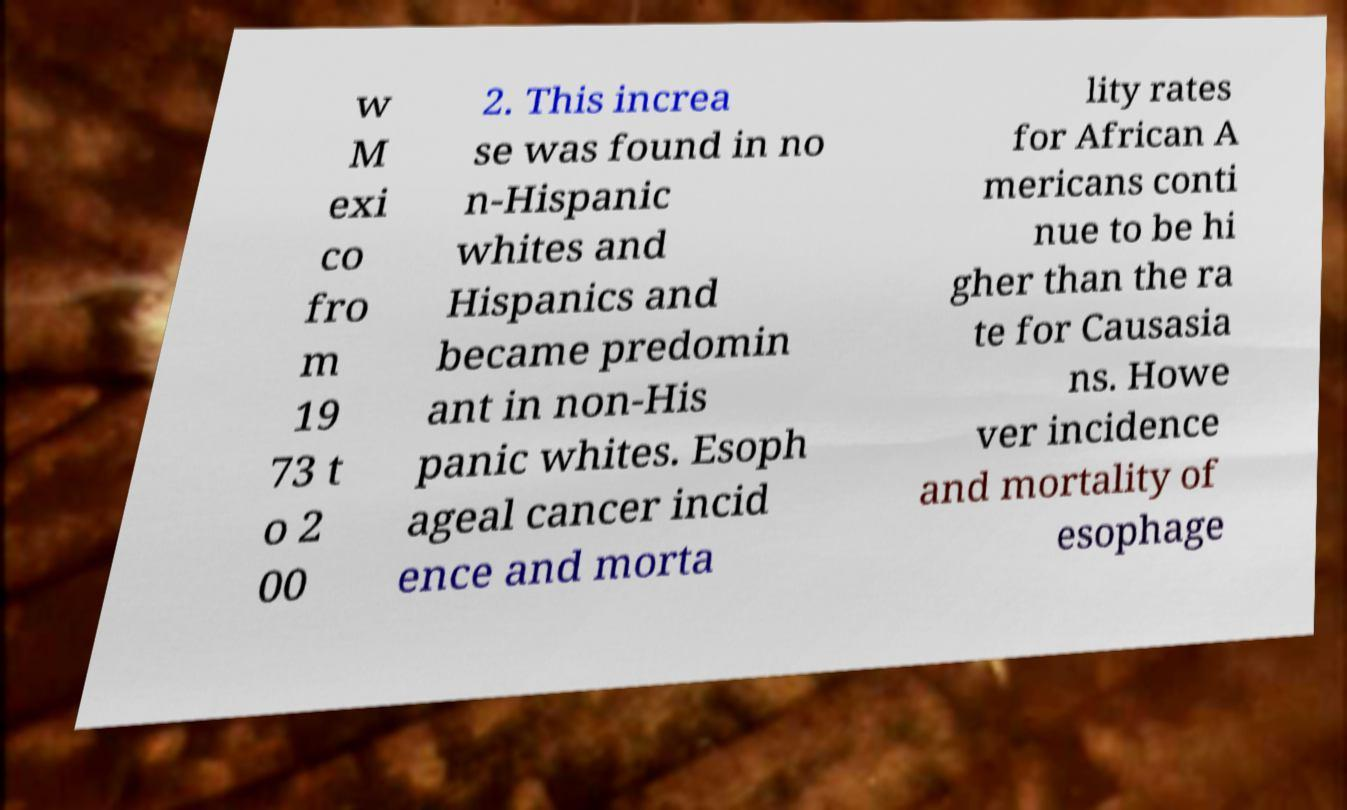For documentation purposes, I need the text within this image transcribed. Could you provide that? w M exi co fro m 19 73 t o 2 00 2. This increa se was found in no n-Hispanic whites and Hispanics and became predomin ant in non-His panic whites. Esoph ageal cancer incid ence and morta lity rates for African A mericans conti nue to be hi gher than the ra te for Causasia ns. Howe ver incidence and mortality of esophage 